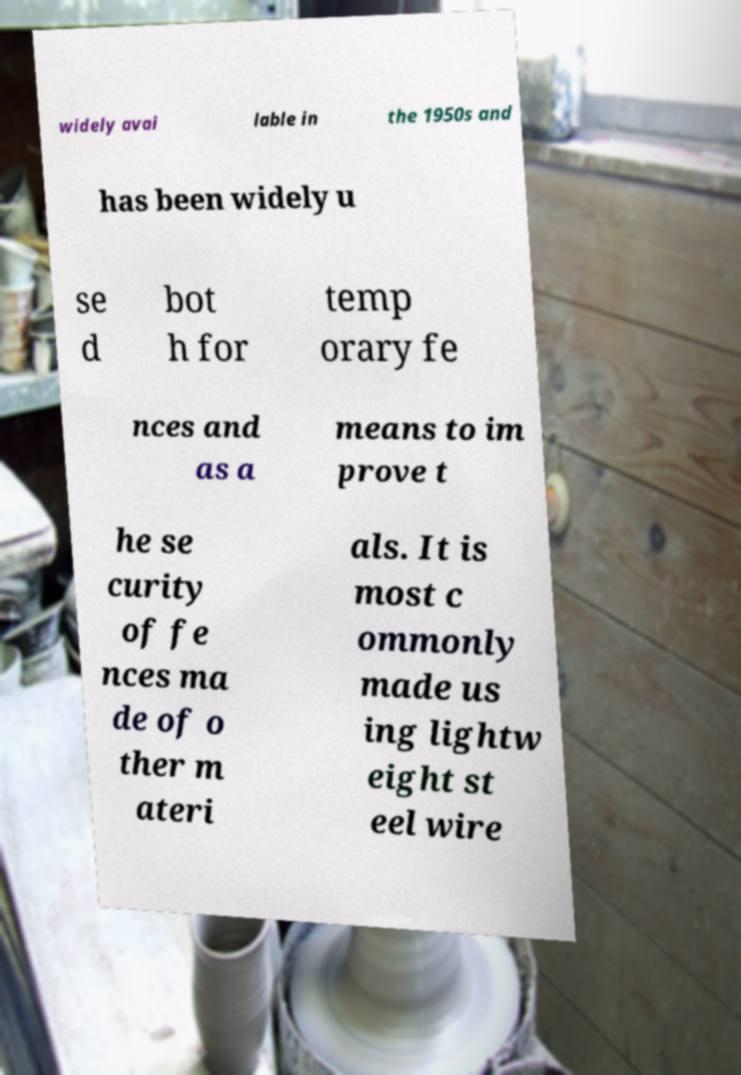Could you assist in decoding the text presented in this image and type it out clearly? widely avai lable in the 1950s and has been widely u se d bot h for temp orary fe nces and as a means to im prove t he se curity of fe nces ma de of o ther m ateri als. It is most c ommonly made us ing lightw eight st eel wire 